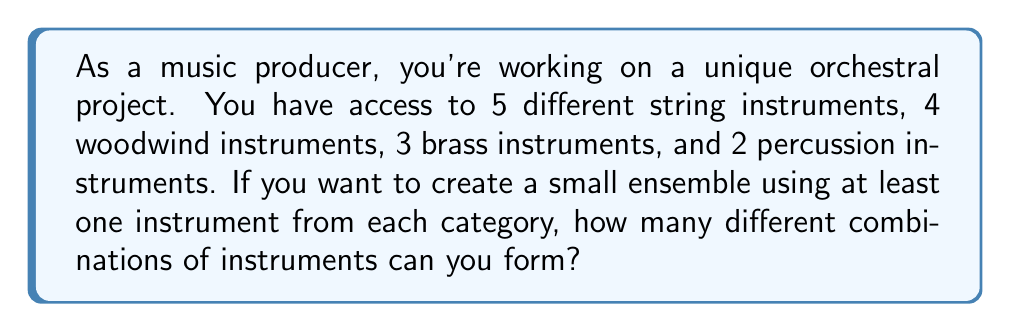Solve this math problem. Let's approach this step-by-step:

1) We need to use at least one instrument from each category. This means we can choose:
   - 1 to 5 string instruments
   - 1 to 4 woodwind instruments
   - 1 to 3 brass instruments
   - 1 to 2 percussion instruments

2) For each category, we need to calculate the number of ways to choose instruments:

   Strings: $\binom{5}{1} + \binom{5}{2} + \binom{5}{3} + \binom{5}{4} + \binom{5}{5} = 31$
   Woodwinds: $\binom{4}{1} + \binom{4}{2} + \binom{4}{3} + \binom{4}{4} = 15$
   Brass: $\binom{3}{1} + \binom{3}{2} + \binom{3}{3} = 7$
   Percussion: $\binom{2}{1} + \binom{2}{2} = 3$

3) According to the multiplication principle, the total number of combinations is the product of these individual choices:

   $$31 \times 15 \times 7 \times 3 = 9765$$

Therefore, there are 9765 different combinations of instruments that can be formed.
Answer: 9765 